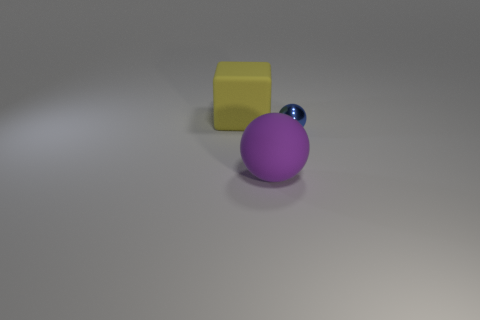There is another object that is the same shape as the large purple rubber object; what is its material?
Offer a very short reply. Metal. Are there any other things that are made of the same material as the block?
Provide a succinct answer. Yes. What material is the thing that is both in front of the rubber block and left of the metal object?
Provide a succinct answer. Rubber. What number of other large yellow things have the same shape as the metallic thing?
Your answer should be compact. 0. There is a object that is left of the matte object that is on the right side of the matte cube; what color is it?
Your answer should be very brief. Yellow. Are there an equal number of yellow matte cubes left of the cube and big cylinders?
Provide a short and direct response. Yes. Is there a purple matte ball of the same size as the yellow thing?
Offer a very short reply. Yes. There is a yellow cube; is its size the same as the object on the right side of the big purple rubber object?
Offer a very short reply. No. Are there an equal number of big rubber cubes in front of the big matte cube and yellow objects that are in front of the big purple object?
Keep it short and to the point. Yes. There is a sphere to the right of the matte ball; what is it made of?
Give a very brief answer. Metal. 